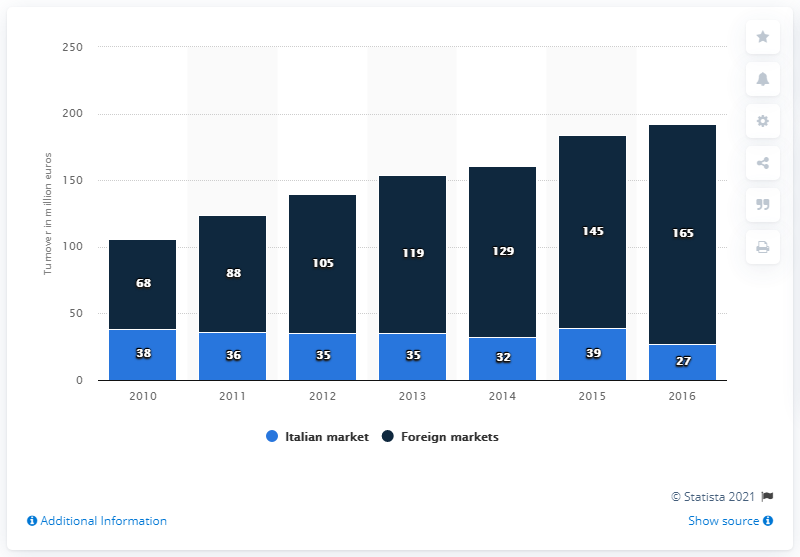Mention a couple of crucial points in this snapshot. Approximately 165% of Zonin's revenues were generated from foreign markets. 